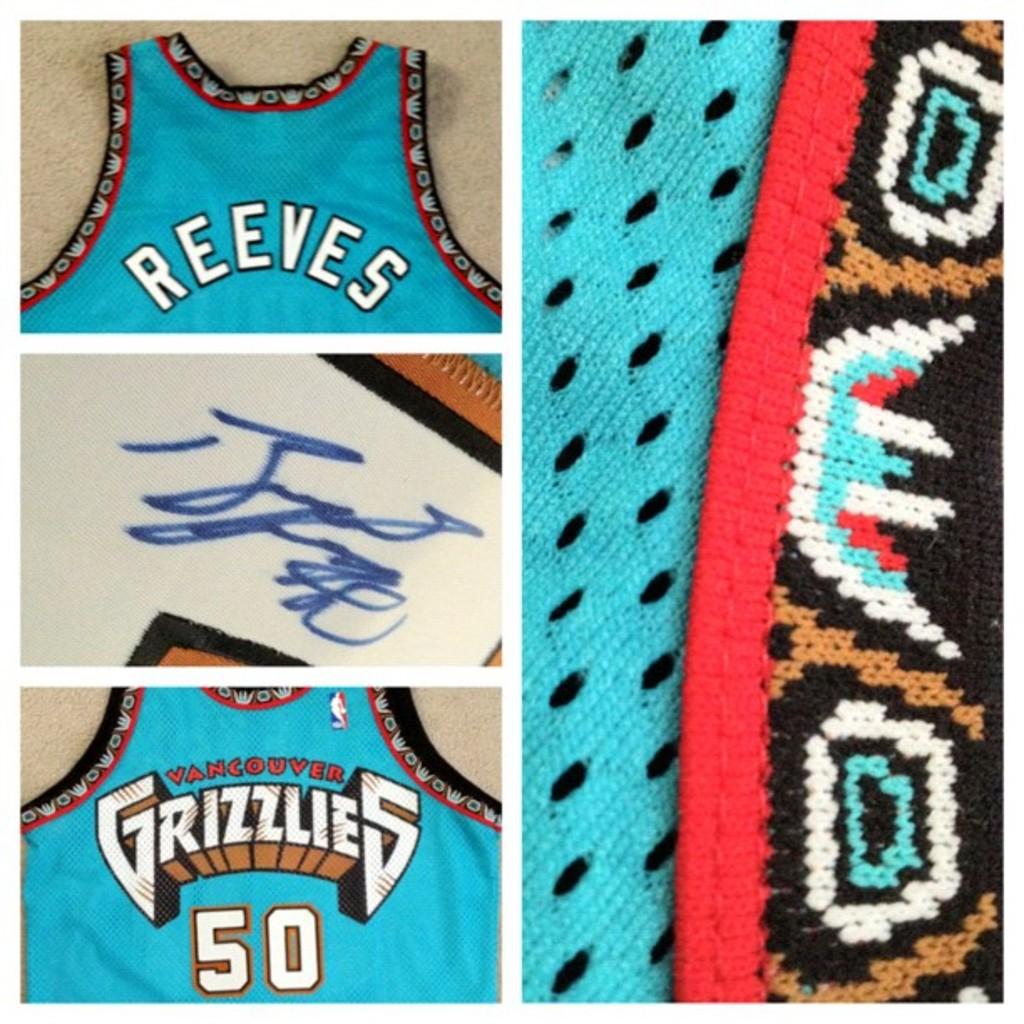Who wears the $50 jersey for grizzlies?
Provide a short and direct response. Reeves. 